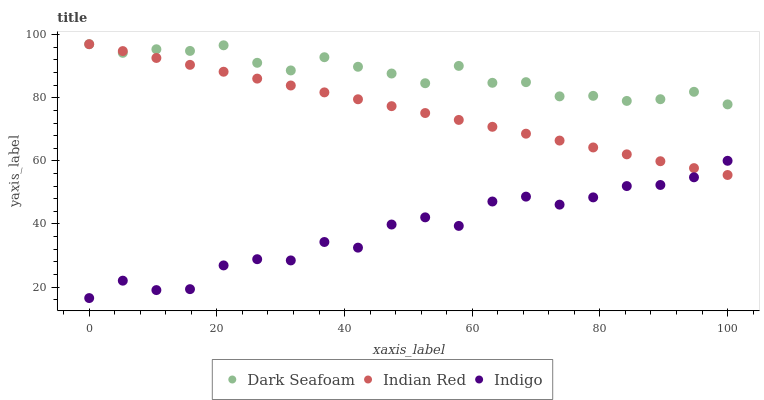Does Indigo have the minimum area under the curve?
Answer yes or no. Yes. Does Dark Seafoam have the maximum area under the curve?
Answer yes or no. Yes. Does Indian Red have the minimum area under the curve?
Answer yes or no. No. Does Indian Red have the maximum area under the curve?
Answer yes or no. No. Is Indian Red the smoothest?
Answer yes or no. Yes. Is Indigo the roughest?
Answer yes or no. Yes. Is Indigo the smoothest?
Answer yes or no. No. Is Indian Red the roughest?
Answer yes or no. No. Does Indigo have the lowest value?
Answer yes or no. Yes. Does Indian Red have the lowest value?
Answer yes or no. No. Does Indian Red have the highest value?
Answer yes or no. Yes. Does Indigo have the highest value?
Answer yes or no. No. Is Indigo less than Dark Seafoam?
Answer yes or no. Yes. Is Dark Seafoam greater than Indigo?
Answer yes or no. Yes. Does Indigo intersect Indian Red?
Answer yes or no. Yes. Is Indigo less than Indian Red?
Answer yes or no. No. Is Indigo greater than Indian Red?
Answer yes or no. No. Does Indigo intersect Dark Seafoam?
Answer yes or no. No. 